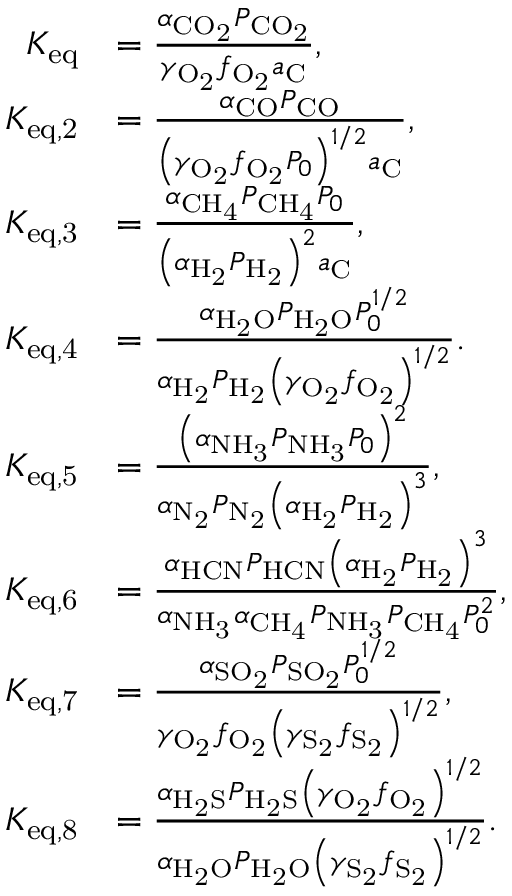<formula> <loc_0><loc_0><loc_500><loc_500>\begin{array} { r l } { K _ { e q } } & { = \frac { \alpha _ { C O _ { 2 } } P _ { C O _ { 2 } } } { \gamma _ { O _ { 2 } } f _ { O _ { 2 } } a _ { C } } , } \\ { K _ { e q , 2 } } & { = \frac { \alpha _ { C O } P _ { C O } } { \left ( \gamma _ { O _ { 2 } } f _ { O _ { 2 } } P _ { 0 } \right ) ^ { 1 / 2 } a _ { C } } , } \\ { K _ { e q , 3 } } & { = \frac { \alpha _ { C H _ { 4 } } P _ { C H _ { 4 } } P _ { 0 } } { \left ( \alpha _ { H _ { 2 } } P _ { H _ { 2 } } \right ) ^ { 2 } a _ { C } } , } \\ { K _ { e q , 4 } } & { = \frac { \alpha _ { H _ { 2 } O } P _ { H _ { 2 } O } P _ { 0 } ^ { 1 / 2 } } { \alpha _ { H _ { 2 } } P _ { H _ { 2 } } \left ( \gamma _ { O _ { 2 } } f _ { O _ { 2 } } \right ) ^ { 1 / 2 } } . } \\ { K _ { e q , 5 } } & { = \frac { \left ( \alpha _ { N H _ { 3 } } P _ { N H _ { 3 } } P _ { 0 } \right ) ^ { 2 } } { \alpha _ { N _ { 2 } } P _ { N _ { 2 } } \left ( \alpha _ { H _ { 2 } } P _ { H _ { 2 } } \right ) ^ { 3 } } , } \\ { K _ { e q , 6 } } & { = \frac { \alpha _ { H C N } P _ { H C N } \left ( \alpha _ { H _ { 2 } } P _ { H _ { 2 } } \right ) ^ { 3 } } { \alpha _ { N H _ { 3 } } \alpha _ { C H _ { 4 } } P _ { N H _ { 3 } } P _ { C H _ { 4 } } P _ { 0 } ^ { 2 } } , } \\ { K _ { e q , 7 } } & { = \frac { \alpha _ { S O _ { 2 } } P _ { S O _ { 2 } } P _ { 0 } ^ { 1 / 2 } } { \gamma _ { O _ { 2 } } f _ { O _ { 2 } } \left ( \gamma _ { S _ { 2 } } f _ { S _ { 2 } } \right ) ^ { 1 / 2 } } , } \\ { K _ { e q , 8 } } & { = \frac { \alpha _ { H _ { 2 } S } P _ { H _ { 2 } S } \left ( \gamma _ { O _ { 2 } } f _ { O _ { 2 } } \right ) ^ { 1 / 2 } } { \alpha _ { H _ { 2 } O } P _ { H _ { 2 } O } \left ( \gamma _ { S _ { 2 } } f _ { S _ { 2 } } \right ) ^ { 1 / 2 } } . } \end{array}</formula> 